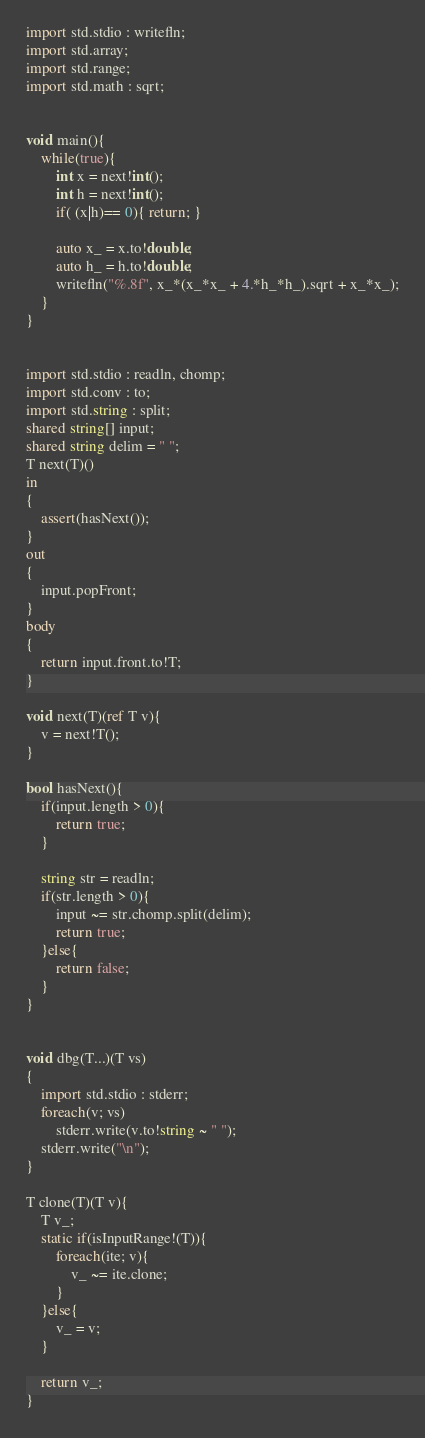<code> <loc_0><loc_0><loc_500><loc_500><_D_>import std.stdio : writefln;
import std.array;
import std.range;
import std.math : sqrt;


void main(){
	while(true){
		int x = next!int();
		int h = next!int();
		if( (x|h)== 0){ return; }
		
		auto x_ = x.to!double;
		auto h_ = h.to!double;
		writefln("%.8f", x_*(x_*x_ + 4.*h_*h_).sqrt + x_*x_);
	}
}


import std.stdio : readln, chomp;
import std.conv : to;
import std.string : split;
shared string[] input;
shared string delim = " ";
T next(T)()
in
{
	assert(hasNext());
}
out
{
	input.popFront;
}
body
{
	return input.front.to!T;
}

void next(T)(ref T v){
	v = next!T();
}

bool hasNext(){
	if(input.length > 0){
		return true;
	}
	
	string str = readln;
	if(str.length > 0){
		input ~= str.chomp.split(delim);
		return true;
	}else{
		return false;
	}
}


void dbg(T...)(T vs)
{
	import std.stdio : stderr;
	foreach(v; vs)
		stderr.write(v.to!string ~ " ");
	stderr.write("\n");
}

T clone(T)(T v){
	T v_;
	static if(isInputRange!(T)){
		foreach(ite; v){
			v_ ~= ite.clone;
		}
	}else{
		v_ = v;
	}
	
	return v_;
}</code> 